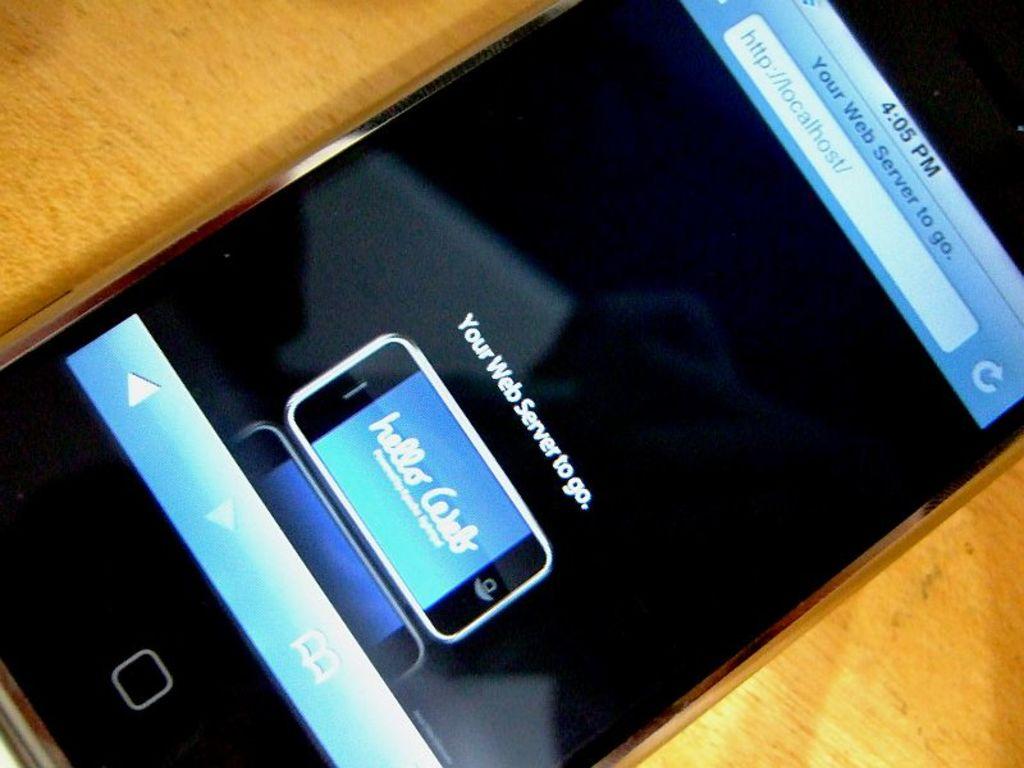What time does the phone show?
Give a very brief answer. 4:05 pm. 